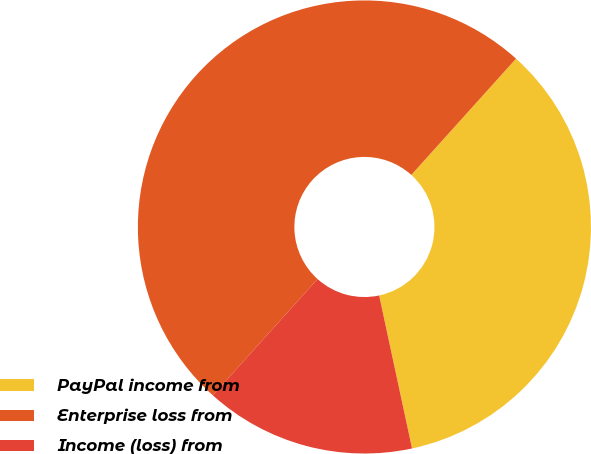Convert chart to OTSL. <chart><loc_0><loc_0><loc_500><loc_500><pie_chart><fcel>PayPal income from<fcel>Enterprise loss from<fcel>Income (loss) from<nl><fcel>34.96%<fcel>50.0%<fcel>15.04%<nl></chart> 